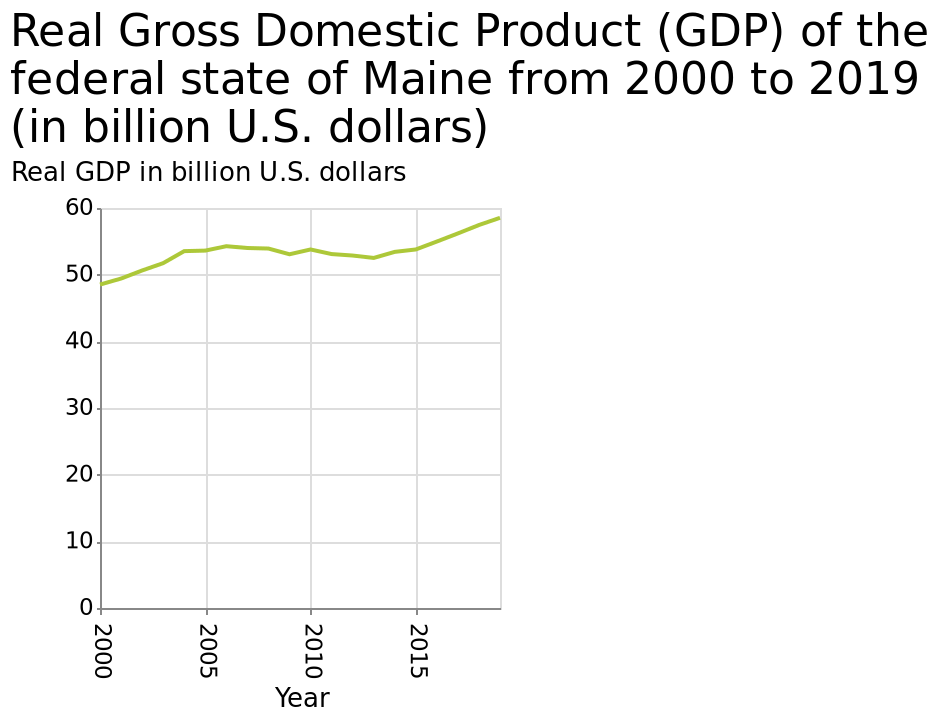<image>
please enumerates aspects of the construction of the chart This is a line diagram named Real Gross Domestic Product (GDP) of the federal state of Maine from 2000 to 2019 (in billion U.S. dollars). The y-axis shows Real GDP in billion U.S. dollars while the x-axis shows Year. What is the name of the line diagram?  The line diagram is named "Real Gross Domestic Product (GDP) of the federal state of Maine from 2000 to 2019". 